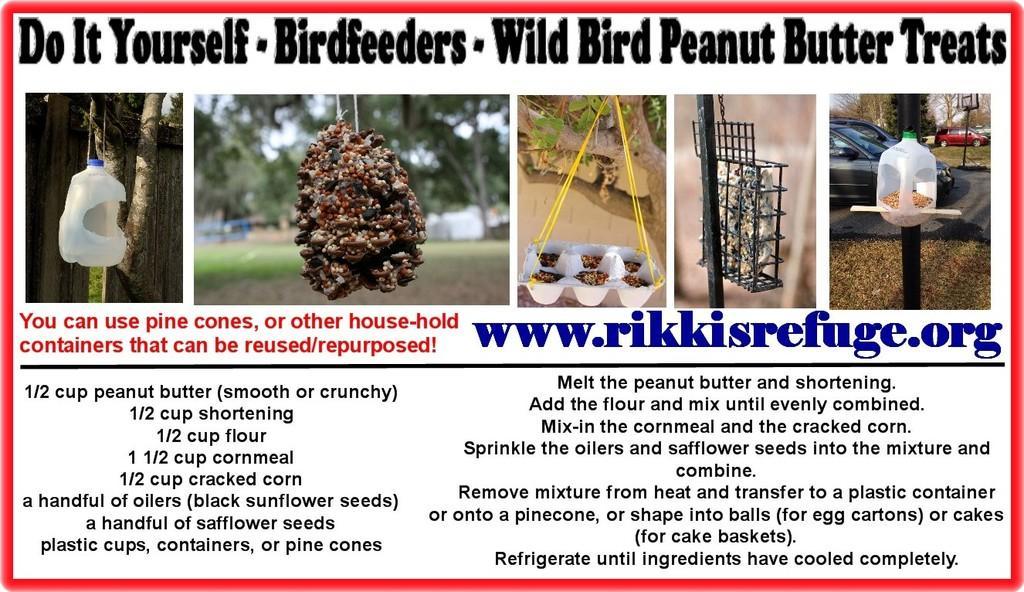Could you give a brief overview of what you see in this image? In the image there is a poster. At the top of the image there is something written on it. There are few colleges. In the first image there is a white bottle with a cut. In the second image there is an object hanging. In the third image white tray hanging with ropes. In the fourth image there is a pole with grill. Inside the girl there is an object. And in the fifth image there is a bottle on the pole. Behind the bottle there are cars and trees. Below these images there is something written on it and also there is a website address. 